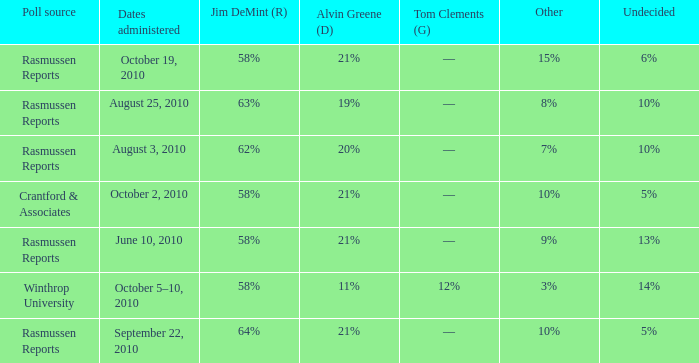What was the vote for Alvin Green when other was 9%? 21%. 